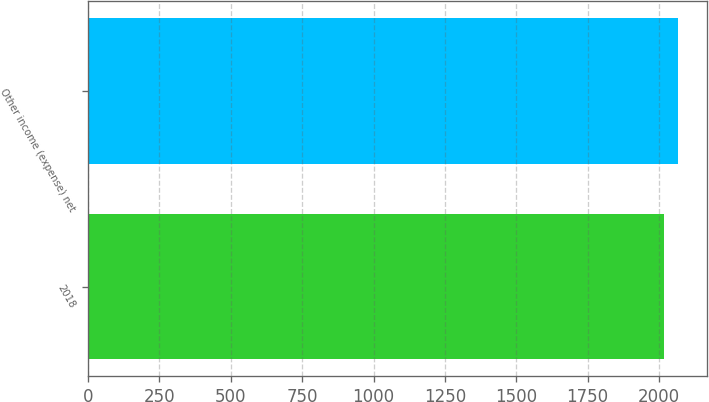Convert chart. <chart><loc_0><loc_0><loc_500><loc_500><bar_chart><fcel>2018<fcel>Other income (expense) net<nl><fcel>2016<fcel>2065<nl></chart> 